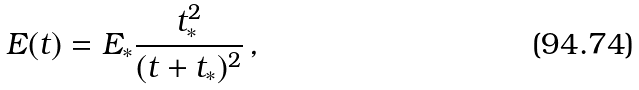Convert formula to latex. <formula><loc_0><loc_0><loc_500><loc_500>E ( t ) = E _ { * } \frac { t _ { * } ^ { 2 } } { ( t + t _ { * } ) ^ { 2 } } \, ,</formula> 